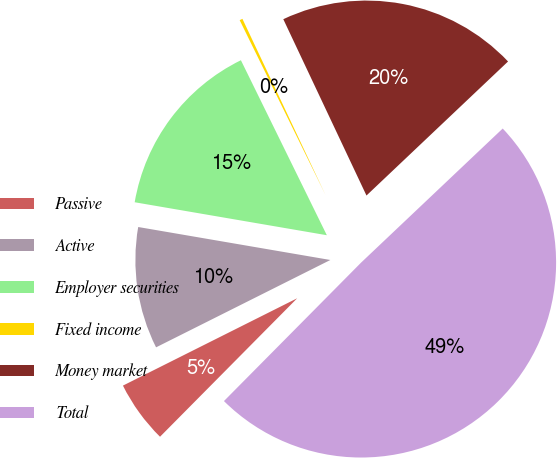<chart> <loc_0><loc_0><loc_500><loc_500><pie_chart><fcel>Passive<fcel>Active<fcel>Employer securities<fcel>Fixed income<fcel>Money market<fcel>Total<nl><fcel>5.18%<fcel>10.1%<fcel>15.03%<fcel>0.25%<fcel>19.95%<fcel>49.49%<nl></chart> 